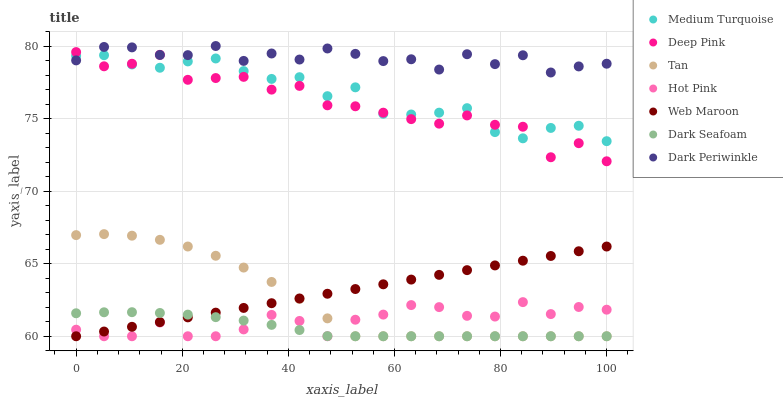Does Dark Seafoam have the minimum area under the curve?
Answer yes or no. Yes. Does Dark Periwinkle have the maximum area under the curve?
Answer yes or no. Yes. Does Hot Pink have the minimum area under the curve?
Answer yes or no. No. Does Hot Pink have the maximum area under the curve?
Answer yes or no. No. Is Web Maroon the smoothest?
Answer yes or no. Yes. Is Deep Pink the roughest?
Answer yes or no. Yes. Is Hot Pink the smoothest?
Answer yes or no. No. Is Hot Pink the roughest?
Answer yes or no. No. Does Hot Pink have the lowest value?
Answer yes or no. Yes. Does Medium Turquoise have the lowest value?
Answer yes or no. No. Does Dark Periwinkle have the highest value?
Answer yes or no. Yes. Does Hot Pink have the highest value?
Answer yes or no. No. Is Hot Pink less than Dark Periwinkle?
Answer yes or no. Yes. Is Medium Turquoise greater than Tan?
Answer yes or no. Yes. Does Hot Pink intersect Web Maroon?
Answer yes or no. Yes. Is Hot Pink less than Web Maroon?
Answer yes or no. No. Is Hot Pink greater than Web Maroon?
Answer yes or no. No. Does Hot Pink intersect Dark Periwinkle?
Answer yes or no. No. 